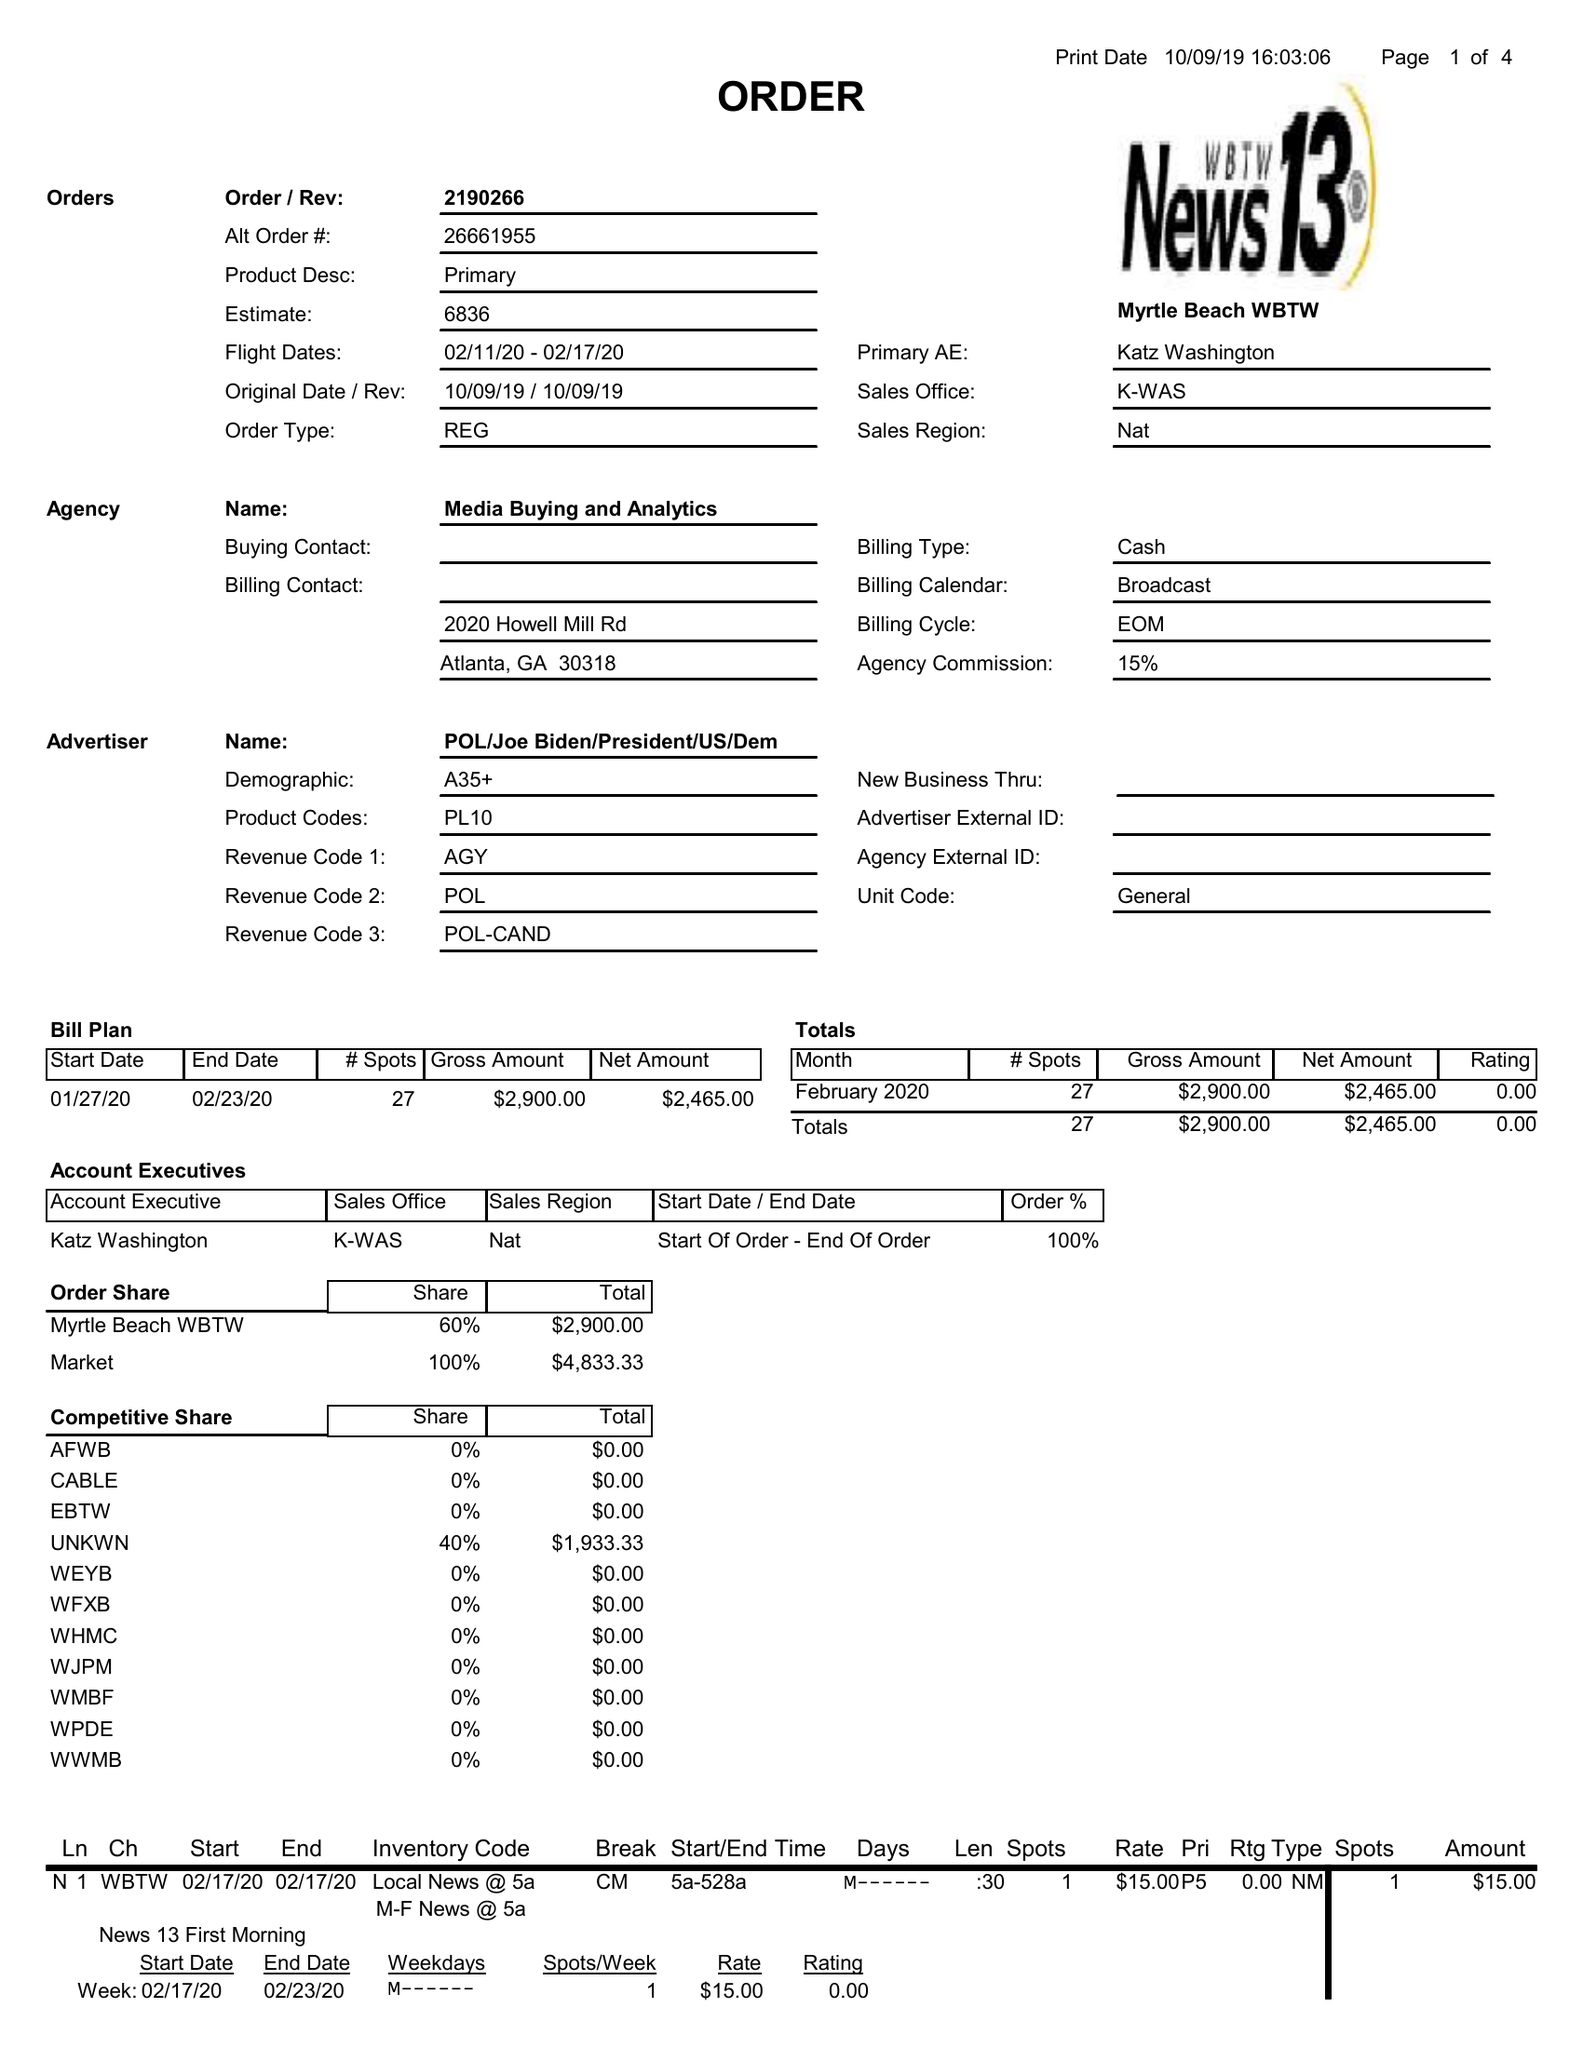What is the value for the advertiser?
Answer the question using a single word or phrase. POL/JOEBIDEN/PRESIDENT/US/DEM 